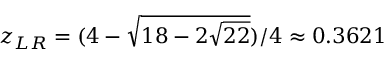Convert formula to latex. <formula><loc_0><loc_0><loc_500><loc_500>z _ { L R } = ( 4 - \sqrt { 1 8 - 2 \sqrt { 2 2 } } ) / 4 \approx 0 . 3 6 2 1</formula> 